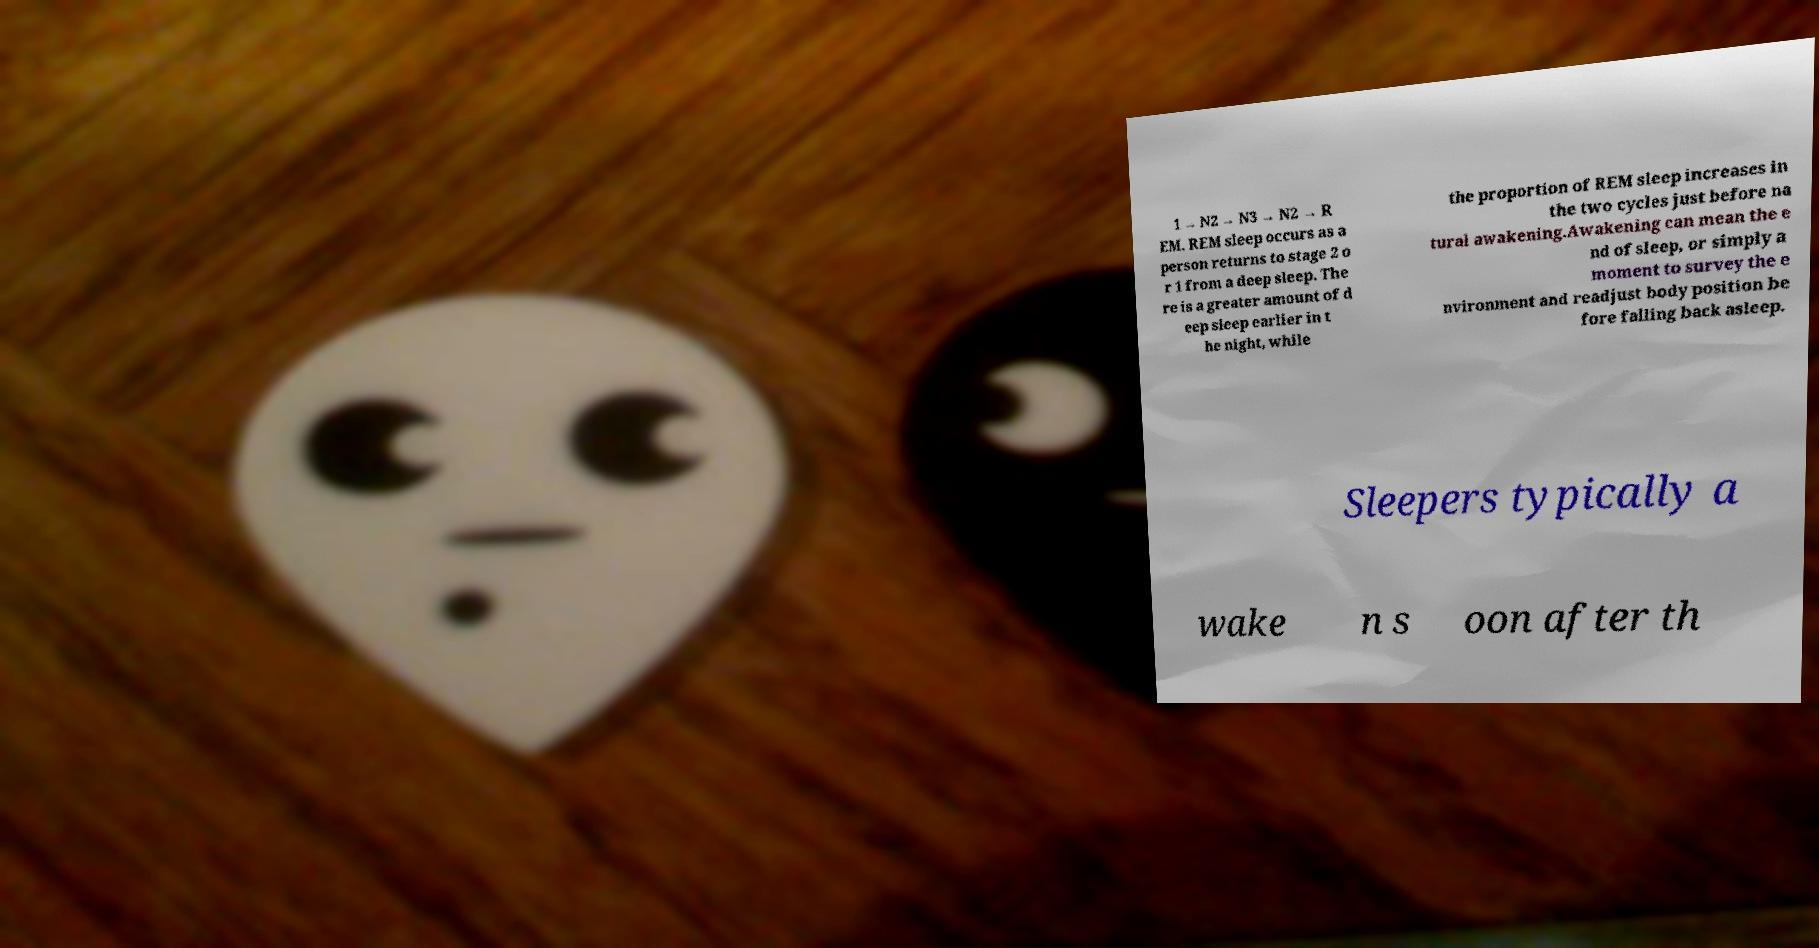Could you extract and type out the text from this image? 1 → N2 → N3 → N2 → R EM. REM sleep occurs as a person returns to stage 2 o r 1 from a deep sleep. The re is a greater amount of d eep sleep earlier in t he night, while the proportion of REM sleep increases in the two cycles just before na tural awakening.Awakening can mean the e nd of sleep, or simply a moment to survey the e nvironment and readjust body position be fore falling back asleep. Sleepers typically a wake n s oon after th 